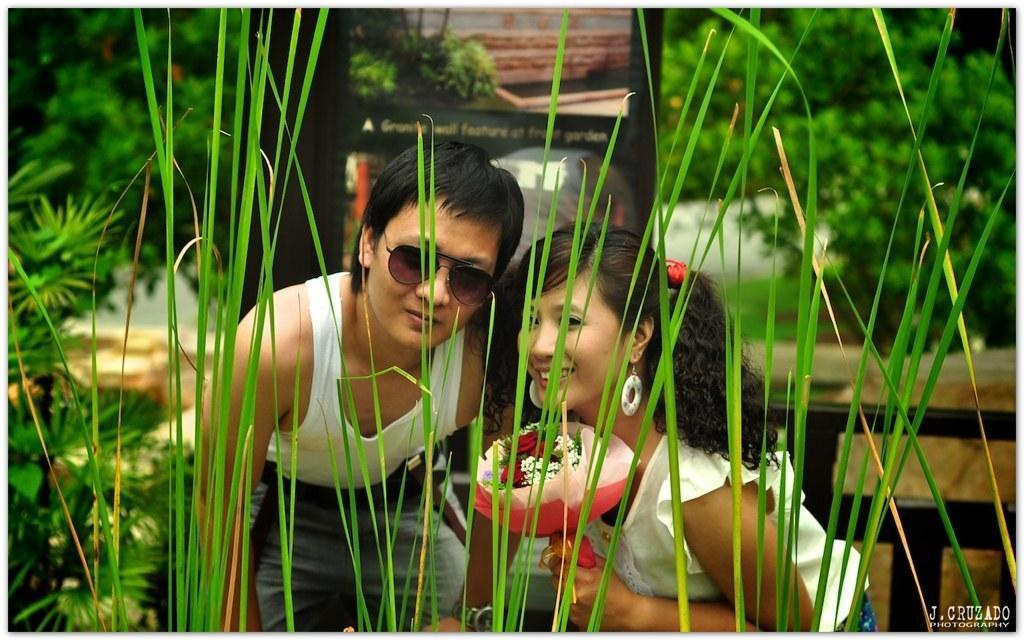Describe this image in one or two sentences. In this image there is a couple standing with a smile on his face, in front of them there are grass and plants, behind them there is a wooden structure and trees. 